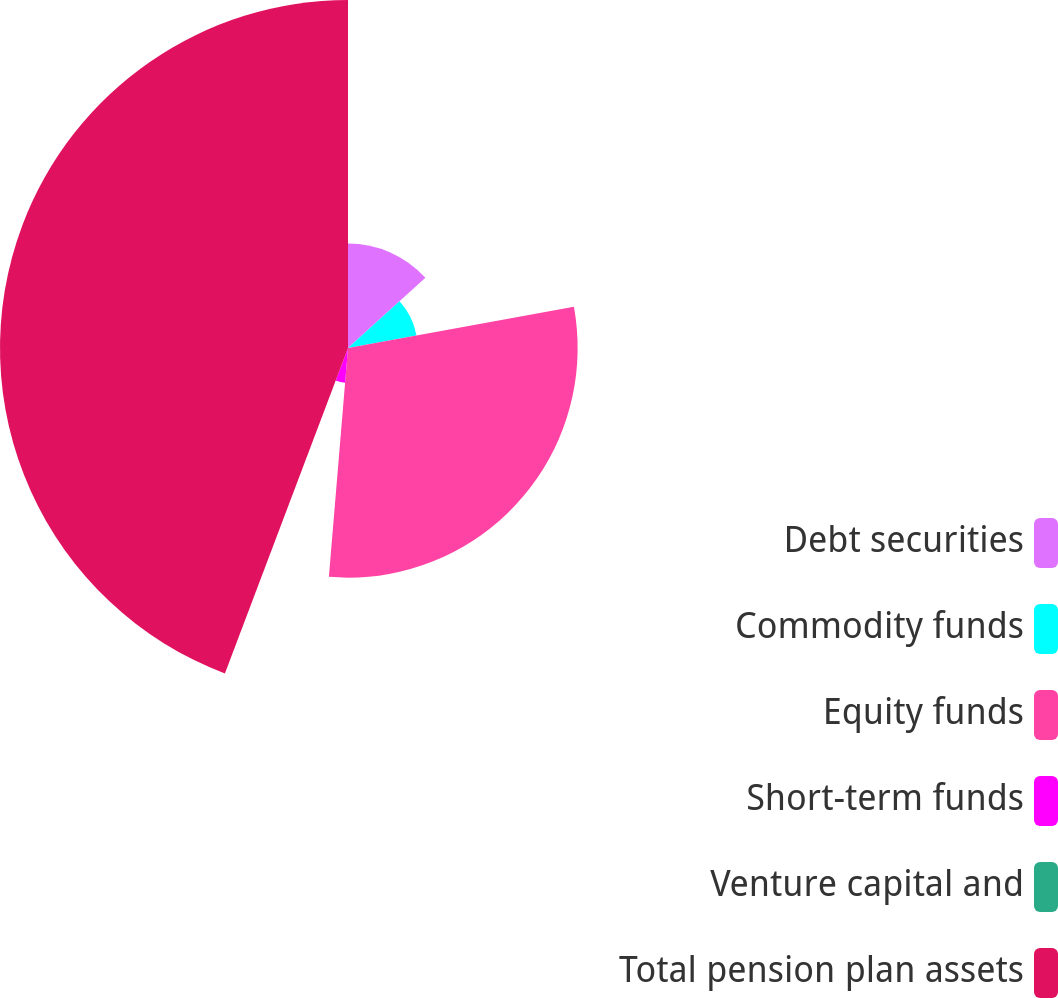Convert chart. <chart><loc_0><loc_0><loc_500><loc_500><pie_chart><fcel>Debt securities<fcel>Commodity funds<fcel>Equity funds<fcel>Short-term funds<fcel>Venture capital and<fcel>Total pension plan assets<nl><fcel>13.28%<fcel>8.85%<fcel>29.2%<fcel>4.43%<fcel>0.0%<fcel>44.25%<nl></chart> 